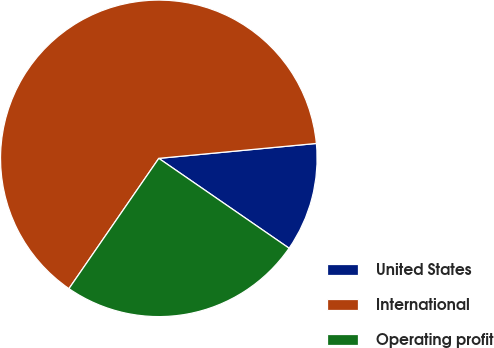Convert chart. <chart><loc_0><loc_0><loc_500><loc_500><pie_chart><fcel>United States<fcel>International<fcel>Operating profit<nl><fcel>11.11%<fcel>63.89%<fcel>25.0%<nl></chart> 